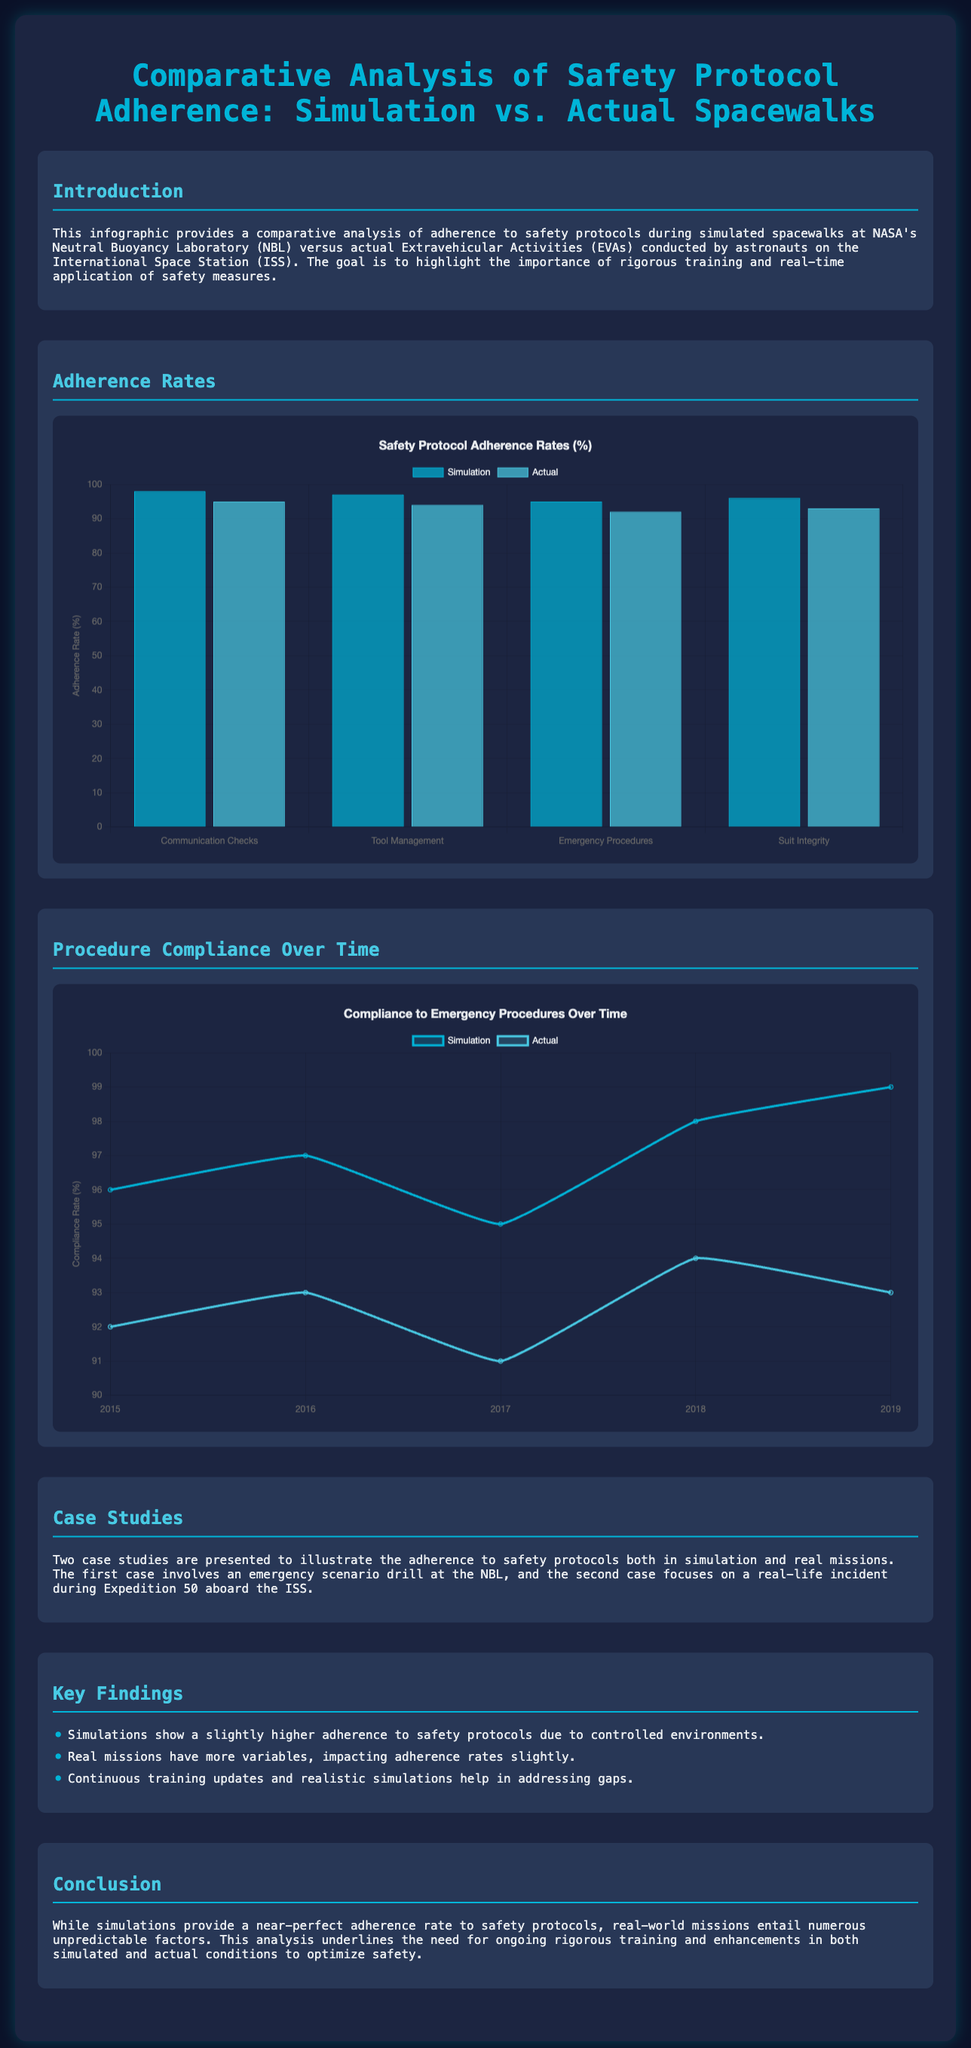What is the title of the infographic? The title of the infographic is prominently displayed at the top of the document.
Answer: Comparative Analysis of Safety Protocol Adherence: Simulation vs. Actual Spacewalks What was the compliance rate for Communication Checks in Simulation? The bar chart shows the adherence rates for different safety protocols in Simulation.
Answer: 98 What year did the Simulation compliance rate reach 99%? The timeline chart indicates the compliance rates over the years, with notable points highlighted.
Answer: 2019 Which procedure had the lowest adherence rate in Actual spacewalks? The bar chart compares the adherence rates for various safety protocols in Actual EVAs.
Answer: Emergency Procedures What trend is observed from the timeline chart for Simulation compliance rates over time? The timeline chart displays the ups and downs in compliance for both Simulation and Actual over five years.
Answer: Increasing What color represents the Simulation data in the bar chart? The colors for the datasets in the bar chart are clearly defined for easy identification.
Answer: Dark blue How many case studies are mentioned in the document? The document mentions the number of case studies providing focus on adherence to safety protocols.
Answer: Two What is mentioned as a significant contributor to the gap in adherence between simulations and actual missions? The text highlights multiple factors affecting the difference in adherence rates during Actual EVAs.
Answer: Unpredictable factors What is the maximum value shown on the y-axis of the adherence bar chart? The y-axis of the bar chart indicates the range of adherence rates to protocols clearly marked.
Answer: 100 